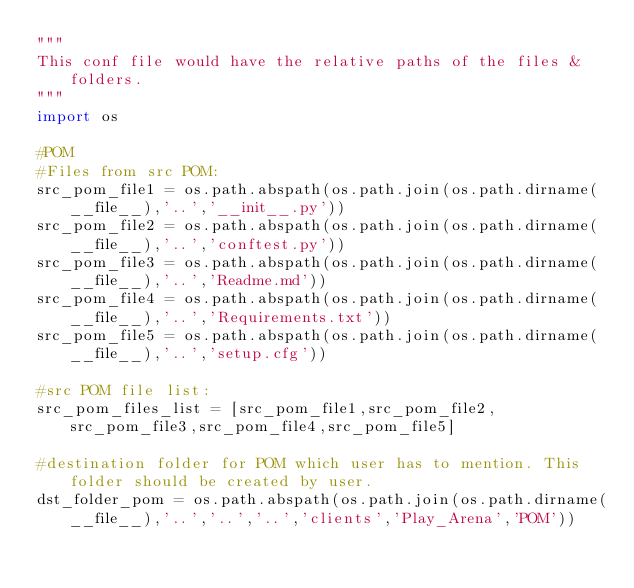<code> <loc_0><loc_0><loc_500><loc_500><_Python_>"""
This conf file would have the relative paths of the files & folders.
"""
import os

#POM
#Files from src POM:
src_pom_file1 = os.path.abspath(os.path.join(os.path.dirname(__file__),'..','__init__.py'))
src_pom_file2 = os.path.abspath(os.path.join(os.path.dirname(__file__),'..','conftest.py'))
src_pom_file3 = os.path.abspath(os.path.join(os.path.dirname(__file__),'..','Readme.md'))
src_pom_file4 = os.path.abspath(os.path.join(os.path.dirname(__file__),'..','Requirements.txt'))
src_pom_file5 = os.path.abspath(os.path.join(os.path.dirname(__file__),'..','setup.cfg'))

#src POM file list:
src_pom_files_list = [src_pom_file1,src_pom_file2,src_pom_file3,src_pom_file4,src_pom_file5]

#destination folder for POM which user has to mention. This folder should be created by user.
dst_folder_pom = os.path.abspath(os.path.join(os.path.dirname(__file__),'..','..','..','clients','Play_Arena','POM'))</code> 